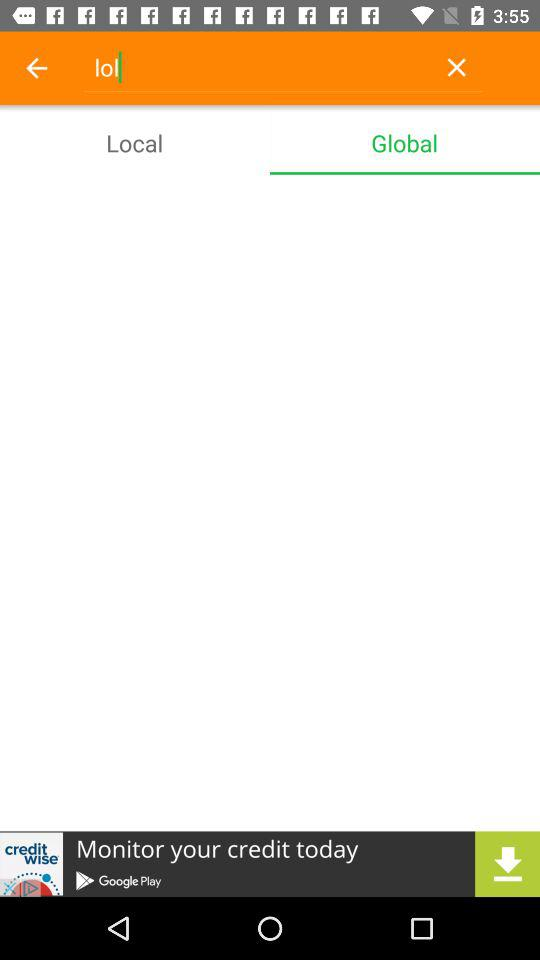Which tab is selected? The selected tab is "Global". 